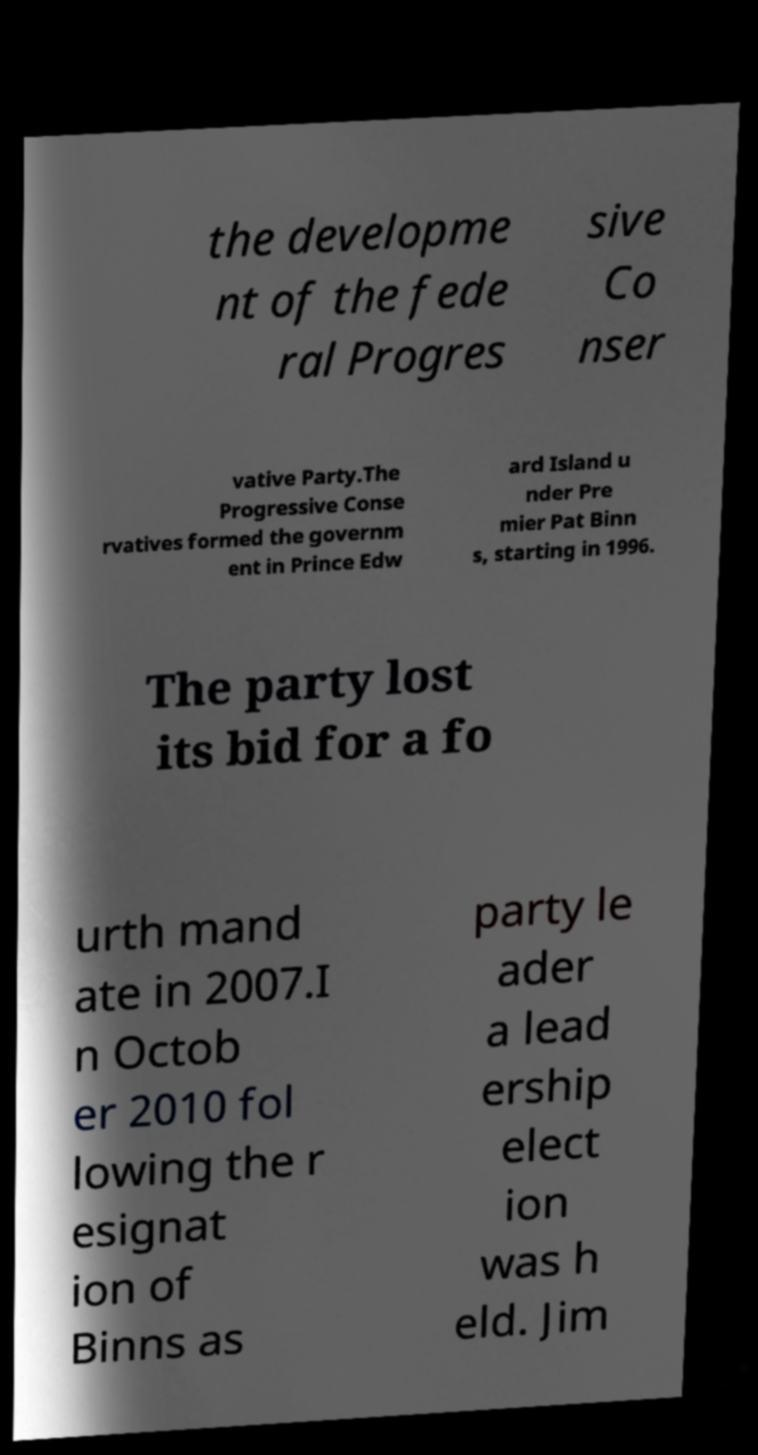Could you assist in decoding the text presented in this image and type it out clearly? the developme nt of the fede ral Progres sive Co nser vative Party.The Progressive Conse rvatives formed the governm ent in Prince Edw ard Island u nder Pre mier Pat Binn s, starting in 1996. The party lost its bid for a fo urth mand ate in 2007.I n Octob er 2010 fol lowing the r esignat ion of Binns as party le ader a lead ership elect ion was h eld. Jim 